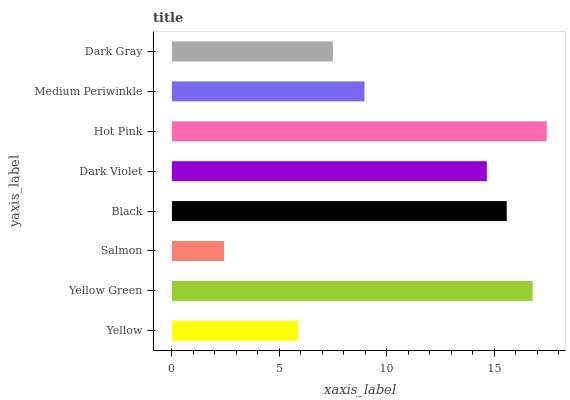Is Salmon the minimum?
Answer yes or no. Yes. Is Hot Pink the maximum?
Answer yes or no. Yes. Is Yellow Green the minimum?
Answer yes or no. No. Is Yellow Green the maximum?
Answer yes or no. No. Is Yellow Green greater than Yellow?
Answer yes or no. Yes. Is Yellow less than Yellow Green?
Answer yes or no. Yes. Is Yellow greater than Yellow Green?
Answer yes or no. No. Is Yellow Green less than Yellow?
Answer yes or no. No. Is Dark Violet the high median?
Answer yes or no. Yes. Is Medium Periwinkle the low median?
Answer yes or no. Yes. Is Yellow Green the high median?
Answer yes or no. No. Is Dark Gray the low median?
Answer yes or no. No. 